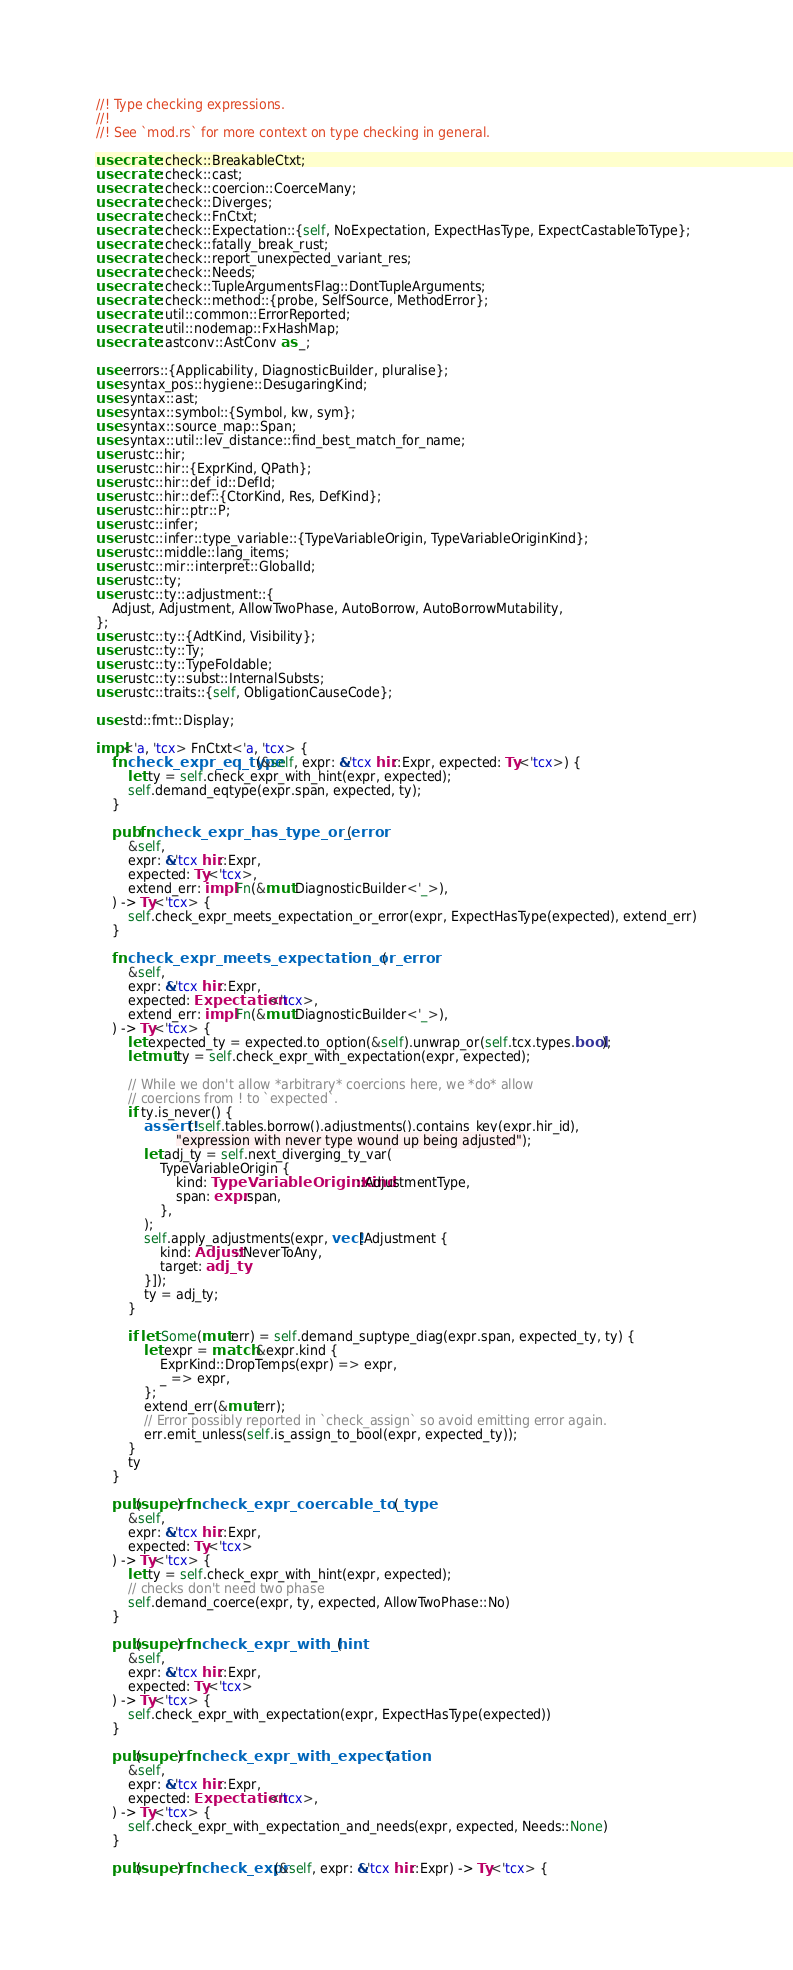Convert code to text. <code><loc_0><loc_0><loc_500><loc_500><_Rust_>//! Type checking expressions.
//!
//! See `mod.rs` for more context on type checking in general.

use crate::check::BreakableCtxt;
use crate::check::cast;
use crate::check::coercion::CoerceMany;
use crate::check::Diverges;
use crate::check::FnCtxt;
use crate::check::Expectation::{self, NoExpectation, ExpectHasType, ExpectCastableToType};
use crate::check::fatally_break_rust;
use crate::check::report_unexpected_variant_res;
use crate::check::Needs;
use crate::check::TupleArgumentsFlag::DontTupleArguments;
use crate::check::method::{probe, SelfSource, MethodError};
use crate::util::common::ErrorReported;
use crate::util::nodemap::FxHashMap;
use crate::astconv::AstConv as _;

use errors::{Applicability, DiagnosticBuilder, pluralise};
use syntax_pos::hygiene::DesugaringKind;
use syntax::ast;
use syntax::symbol::{Symbol, kw, sym};
use syntax::source_map::Span;
use syntax::util::lev_distance::find_best_match_for_name;
use rustc::hir;
use rustc::hir::{ExprKind, QPath};
use rustc::hir::def_id::DefId;
use rustc::hir::def::{CtorKind, Res, DefKind};
use rustc::hir::ptr::P;
use rustc::infer;
use rustc::infer::type_variable::{TypeVariableOrigin, TypeVariableOriginKind};
use rustc::middle::lang_items;
use rustc::mir::interpret::GlobalId;
use rustc::ty;
use rustc::ty::adjustment::{
    Adjust, Adjustment, AllowTwoPhase, AutoBorrow, AutoBorrowMutability,
};
use rustc::ty::{AdtKind, Visibility};
use rustc::ty::Ty;
use rustc::ty::TypeFoldable;
use rustc::ty::subst::InternalSubsts;
use rustc::traits::{self, ObligationCauseCode};

use std::fmt::Display;

impl<'a, 'tcx> FnCtxt<'a, 'tcx> {
    fn check_expr_eq_type(&self, expr: &'tcx hir::Expr, expected: Ty<'tcx>) {
        let ty = self.check_expr_with_hint(expr, expected);
        self.demand_eqtype(expr.span, expected, ty);
    }

    pub fn check_expr_has_type_or_error(
        &self,
        expr: &'tcx hir::Expr,
        expected: Ty<'tcx>,
        extend_err: impl Fn(&mut DiagnosticBuilder<'_>),
    ) -> Ty<'tcx> {
        self.check_expr_meets_expectation_or_error(expr, ExpectHasType(expected), extend_err)
    }

    fn check_expr_meets_expectation_or_error(
        &self,
        expr: &'tcx hir::Expr,
        expected: Expectation<'tcx>,
        extend_err: impl Fn(&mut DiagnosticBuilder<'_>),
    ) -> Ty<'tcx> {
        let expected_ty = expected.to_option(&self).unwrap_or(self.tcx.types.bool);
        let mut ty = self.check_expr_with_expectation(expr, expected);

        // While we don't allow *arbitrary* coercions here, we *do* allow
        // coercions from ! to `expected`.
        if ty.is_never() {
            assert!(!self.tables.borrow().adjustments().contains_key(expr.hir_id),
                    "expression with never type wound up being adjusted");
            let adj_ty = self.next_diverging_ty_var(
                TypeVariableOrigin {
                    kind: TypeVariableOriginKind::AdjustmentType,
                    span: expr.span,
                },
            );
            self.apply_adjustments(expr, vec![Adjustment {
                kind: Adjust::NeverToAny,
                target: adj_ty
            }]);
            ty = adj_ty;
        }

        if let Some(mut err) = self.demand_suptype_diag(expr.span, expected_ty, ty) {
            let expr = match &expr.kind {
                ExprKind::DropTemps(expr) => expr,
                _ => expr,
            };
            extend_err(&mut err);
            // Error possibly reported in `check_assign` so avoid emitting error again.
            err.emit_unless(self.is_assign_to_bool(expr, expected_ty));
        }
        ty
    }

    pub(super) fn check_expr_coercable_to_type(
        &self,
        expr: &'tcx hir::Expr,
        expected: Ty<'tcx>
    ) -> Ty<'tcx> {
        let ty = self.check_expr_with_hint(expr, expected);
        // checks don't need two phase
        self.demand_coerce(expr, ty, expected, AllowTwoPhase::No)
    }

    pub(super) fn check_expr_with_hint(
        &self,
        expr: &'tcx hir::Expr,
        expected: Ty<'tcx>
    ) -> Ty<'tcx> {
        self.check_expr_with_expectation(expr, ExpectHasType(expected))
    }

    pub(super) fn check_expr_with_expectation(
        &self,
        expr: &'tcx hir::Expr,
        expected: Expectation<'tcx>,
    ) -> Ty<'tcx> {
        self.check_expr_with_expectation_and_needs(expr, expected, Needs::None)
    }

    pub(super) fn check_expr(&self, expr: &'tcx hir::Expr) -> Ty<'tcx> {</code> 